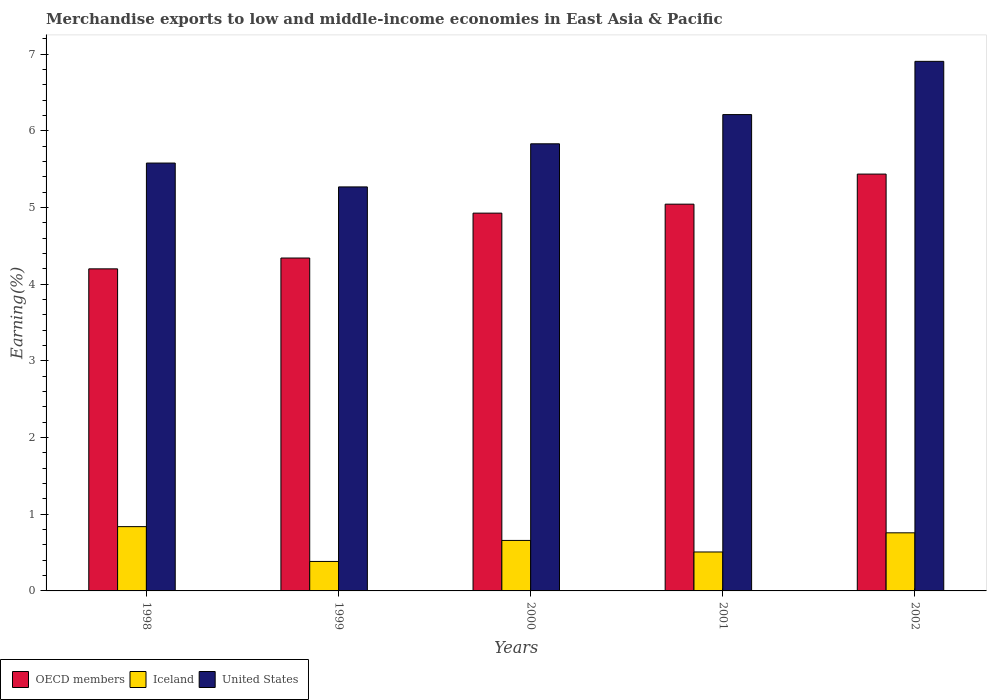How many different coloured bars are there?
Keep it short and to the point. 3. Are the number of bars per tick equal to the number of legend labels?
Make the answer very short. Yes. Are the number of bars on each tick of the X-axis equal?
Your answer should be very brief. Yes. How many bars are there on the 3rd tick from the left?
Keep it short and to the point. 3. How many bars are there on the 5th tick from the right?
Offer a very short reply. 3. What is the percentage of amount earned from merchandise exports in United States in 2000?
Give a very brief answer. 5.83. Across all years, what is the maximum percentage of amount earned from merchandise exports in OECD members?
Provide a succinct answer. 5.44. Across all years, what is the minimum percentage of amount earned from merchandise exports in United States?
Your response must be concise. 5.27. In which year was the percentage of amount earned from merchandise exports in Iceland maximum?
Offer a terse response. 1998. In which year was the percentage of amount earned from merchandise exports in United States minimum?
Your response must be concise. 1999. What is the total percentage of amount earned from merchandise exports in Iceland in the graph?
Your answer should be compact. 3.15. What is the difference between the percentage of amount earned from merchandise exports in Iceland in 2001 and that in 2002?
Your answer should be very brief. -0.25. What is the difference between the percentage of amount earned from merchandise exports in Iceland in 2001 and the percentage of amount earned from merchandise exports in OECD members in 2002?
Provide a succinct answer. -4.93. What is the average percentage of amount earned from merchandise exports in Iceland per year?
Your answer should be compact. 0.63. In the year 2000, what is the difference between the percentage of amount earned from merchandise exports in Iceland and percentage of amount earned from merchandise exports in OECD members?
Provide a short and direct response. -4.27. What is the ratio of the percentage of amount earned from merchandise exports in OECD members in 2000 to that in 2002?
Give a very brief answer. 0.91. What is the difference between the highest and the second highest percentage of amount earned from merchandise exports in Iceland?
Provide a short and direct response. 0.08. What is the difference between the highest and the lowest percentage of amount earned from merchandise exports in Iceland?
Give a very brief answer. 0.45. In how many years, is the percentage of amount earned from merchandise exports in Iceland greater than the average percentage of amount earned from merchandise exports in Iceland taken over all years?
Offer a very short reply. 3. Is the sum of the percentage of amount earned from merchandise exports in OECD members in 1998 and 2002 greater than the maximum percentage of amount earned from merchandise exports in United States across all years?
Your response must be concise. Yes. What does the 2nd bar from the left in 1998 represents?
Ensure brevity in your answer.  Iceland. What does the 1st bar from the right in 1998 represents?
Your response must be concise. United States. Is it the case that in every year, the sum of the percentage of amount earned from merchandise exports in OECD members and percentage of amount earned from merchandise exports in United States is greater than the percentage of amount earned from merchandise exports in Iceland?
Provide a succinct answer. Yes. How many bars are there?
Your response must be concise. 15. Are all the bars in the graph horizontal?
Your response must be concise. No. What is the difference between two consecutive major ticks on the Y-axis?
Offer a terse response. 1. Are the values on the major ticks of Y-axis written in scientific E-notation?
Offer a terse response. No. Does the graph contain any zero values?
Keep it short and to the point. No. Does the graph contain grids?
Provide a succinct answer. No. How are the legend labels stacked?
Offer a very short reply. Horizontal. What is the title of the graph?
Your answer should be compact. Merchandise exports to low and middle-income economies in East Asia & Pacific. Does "Fiji" appear as one of the legend labels in the graph?
Your answer should be compact. No. What is the label or title of the X-axis?
Ensure brevity in your answer.  Years. What is the label or title of the Y-axis?
Your response must be concise. Earning(%). What is the Earning(%) in OECD members in 1998?
Your answer should be compact. 4.2. What is the Earning(%) in Iceland in 1998?
Your answer should be compact. 0.84. What is the Earning(%) of United States in 1998?
Offer a terse response. 5.58. What is the Earning(%) of OECD members in 1999?
Provide a short and direct response. 4.34. What is the Earning(%) in Iceland in 1999?
Keep it short and to the point. 0.38. What is the Earning(%) of United States in 1999?
Your answer should be compact. 5.27. What is the Earning(%) in OECD members in 2000?
Keep it short and to the point. 4.93. What is the Earning(%) of Iceland in 2000?
Provide a succinct answer. 0.66. What is the Earning(%) in United States in 2000?
Your answer should be very brief. 5.83. What is the Earning(%) in OECD members in 2001?
Your answer should be compact. 5.05. What is the Earning(%) of Iceland in 2001?
Make the answer very short. 0.51. What is the Earning(%) of United States in 2001?
Give a very brief answer. 6.21. What is the Earning(%) in OECD members in 2002?
Your response must be concise. 5.44. What is the Earning(%) in Iceland in 2002?
Your answer should be very brief. 0.76. What is the Earning(%) in United States in 2002?
Give a very brief answer. 6.91. Across all years, what is the maximum Earning(%) of OECD members?
Offer a very short reply. 5.44. Across all years, what is the maximum Earning(%) in Iceland?
Give a very brief answer. 0.84. Across all years, what is the maximum Earning(%) of United States?
Keep it short and to the point. 6.91. Across all years, what is the minimum Earning(%) of OECD members?
Your answer should be very brief. 4.2. Across all years, what is the minimum Earning(%) in Iceland?
Ensure brevity in your answer.  0.38. Across all years, what is the minimum Earning(%) in United States?
Offer a very short reply. 5.27. What is the total Earning(%) in OECD members in the graph?
Your answer should be very brief. 23.96. What is the total Earning(%) of Iceland in the graph?
Your response must be concise. 3.15. What is the total Earning(%) in United States in the graph?
Provide a succinct answer. 29.81. What is the difference between the Earning(%) in OECD members in 1998 and that in 1999?
Ensure brevity in your answer.  -0.14. What is the difference between the Earning(%) of Iceland in 1998 and that in 1999?
Provide a short and direct response. 0.45. What is the difference between the Earning(%) of United States in 1998 and that in 1999?
Ensure brevity in your answer.  0.31. What is the difference between the Earning(%) in OECD members in 1998 and that in 2000?
Your answer should be compact. -0.73. What is the difference between the Earning(%) of Iceland in 1998 and that in 2000?
Your answer should be compact. 0.18. What is the difference between the Earning(%) of United States in 1998 and that in 2000?
Your answer should be compact. -0.25. What is the difference between the Earning(%) in OECD members in 1998 and that in 2001?
Offer a terse response. -0.84. What is the difference between the Earning(%) in Iceland in 1998 and that in 2001?
Provide a short and direct response. 0.33. What is the difference between the Earning(%) in United States in 1998 and that in 2001?
Provide a short and direct response. -0.63. What is the difference between the Earning(%) in OECD members in 1998 and that in 2002?
Offer a very short reply. -1.24. What is the difference between the Earning(%) of Iceland in 1998 and that in 2002?
Make the answer very short. 0.08. What is the difference between the Earning(%) in United States in 1998 and that in 2002?
Make the answer very short. -1.33. What is the difference between the Earning(%) of OECD members in 1999 and that in 2000?
Provide a short and direct response. -0.59. What is the difference between the Earning(%) in Iceland in 1999 and that in 2000?
Provide a succinct answer. -0.27. What is the difference between the Earning(%) of United States in 1999 and that in 2000?
Provide a succinct answer. -0.56. What is the difference between the Earning(%) in OECD members in 1999 and that in 2001?
Make the answer very short. -0.7. What is the difference between the Earning(%) of Iceland in 1999 and that in 2001?
Offer a very short reply. -0.12. What is the difference between the Earning(%) in United States in 1999 and that in 2001?
Provide a succinct answer. -0.94. What is the difference between the Earning(%) of OECD members in 1999 and that in 2002?
Give a very brief answer. -1.09. What is the difference between the Earning(%) in Iceland in 1999 and that in 2002?
Provide a short and direct response. -0.37. What is the difference between the Earning(%) in United States in 1999 and that in 2002?
Ensure brevity in your answer.  -1.64. What is the difference between the Earning(%) of OECD members in 2000 and that in 2001?
Ensure brevity in your answer.  -0.12. What is the difference between the Earning(%) in Iceland in 2000 and that in 2001?
Your answer should be compact. 0.15. What is the difference between the Earning(%) in United States in 2000 and that in 2001?
Give a very brief answer. -0.38. What is the difference between the Earning(%) of OECD members in 2000 and that in 2002?
Offer a very short reply. -0.51. What is the difference between the Earning(%) of Iceland in 2000 and that in 2002?
Make the answer very short. -0.1. What is the difference between the Earning(%) in United States in 2000 and that in 2002?
Your response must be concise. -1.08. What is the difference between the Earning(%) in OECD members in 2001 and that in 2002?
Give a very brief answer. -0.39. What is the difference between the Earning(%) in United States in 2001 and that in 2002?
Your response must be concise. -0.69. What is the difference between the Earning(%) of OECD members in 1998 and the Earning(%) of Iceland in 1999?
Keep it short and to the point. 3.82. What is the difference between the Earning(%) in OECD members in 1998 and the Earning(%) in United States in 1999?
Offer a terse response. -1.07. What is the difference between the Earning(%) of Iceland in 1998 and the Earning(%) of United States in 1999?
Your response must be concise. -4.43. What is the difference between the Earning(%) of OECD members in 1998 and the Earning(%) of Iceland in 2000?
Your answer should be compact. 3.54. What is the difference between the Earning(%) of OECD members in 1998 and the Earning(%) of United States in 2000?
Offer a terse response. -1.63. What is the difference between the Earning(%) of Iceland in 1998 and the Earning(%) of United States in 2000?
Ensure brevity in your answer.  -4.99. What is the difference between the Earning(%) in OECD members in 1998 and the Earning(%) in Iceland in 2001?
Your response must be concise. 3.69. What is the difference between the Earning(%) in OECD members in 1998 and the Earning(%) in United States in 2001?
Keep it short and to the point. -2.01. What is the difference between the Earning(%) in Iceland in 1998 and the Earning(%) in United States in 2001?
Your answer should be compact. -5.38. What is the difference between the Earning(%) in OECD members in 1998 and the Earning(%) in Iceland in 2002?
Your answer should be compact. 3.44. What is the difference between the Earning(%) in OECD members in 1998 and the Earning(%) in United States in 2002?
Offer a terse response. -2.71. What is the difference between the Earning(%) of Iceland in 1998 and the Earning(%) of United States in 2002?
Give a very brief answer. -6.07. What is the difference between the Earning(%) in OECD members in 1999 and the Earning(%) in Iceland in 2000?
Your answer should be very brief. 3.68. What is the difference between the Earning(%) of OECD members in 1999 and the Earning(%) of United States in 2000?
Keep it short and to the point. -1.49. What is the difference between the Earning(%) of Iceland in 1999 and the Earning(%) of United States in 2000?
Give a very brief answer. -5.45. What is the difference between the Earning(%) of OECD members in 1999 and the Earning(%) of Iceland in 2001?
Provide a short and direct response. 3.83. What is the difference between the Earning(%) in OECD members in 1999 and the Earning(%) in United States in 2001?
Give a very brief answer. -1.87. What is the difference between the Earning(%) of Iceland in 1999 and the Earning(%) of United States in 2001?
Your answer should be compact. -5.83. What is the difference between the Earning(%) of OECD members in 1999 and the Earning(%) of Iceland in 2002?
Offer a terse response. 3.58. What is the difference between the Earning(%) in OECD members in 1999 and the Earning(%) in United States in 2002?
Your answer should be very brief. -2.57. What is the difference between the Earning(%) in Iceland in 1999 and the Earning(%) in United States in 2002?
Provide a succinct answer. -6.52. What is the difference between the Earning(%) in OECD members in 2000 and the Earning(%) in Iceland in 2001?
Your answer should be compact. 4.42. What is the difference between the Earning(%) of OECD members in 2000 and the Earning(%) of United States in 2001?
Your response must be concise. -1.29. What is the difference between the Earning(%) of Iceland in 2000 and the Earning(%) of United States in 2001?
Your answer should be compact. -5.55. What is the difference between the Earning(%) of OECD members in 2000 and the Earning(%) of Iceland in 2002?
Provide a succinct answer. 4.17. What is the difference between the Earning(%) of OECD members in 2000 and the Earning(%) of United States in 2002?
Your answer should be compact. -1.98. What is the difference between the Earning(%) of Iceland in 2000 and the Earning(%) of United States in 2002?
Offer a very short reply. -6.25. What is the difference between the Earning(%) in OECD members in 2001 and the Earning(%) in Iceland in 2002?
Give a very brief answer. 4.29. What is the difference between the Earning(%) of OECD members in 2001 and the Earning(%) of United States in 2002?
Your answer should be compact. -1.86. What is the difference between the Earning(%) of Iceland in 2001 and the Earning(%) of United States in 2002?
Make the answer very short. -6.4. What is the average Earning(%) of OECD members per year?
Ensure brevity in your answer.  4.79. What is the average Earning(%) in Iceland per year?
Ensure brevity in your answer.  0.63. What is the average Earning(%) in United States per year?
Offer a terse response. 5.96. In the year 1998, what is the difference between the Earning(%) in OECD members and Earning(%) in Iceland?
Make the answer very short. 3.36. In the year 1998, what is the difference between the Earning(%) in OECD members and Earning(%) in United States?
Give a very brief answer. -1.38. In the year 1998, what is the difference between the Earning(%) of Iceland and Earning(%) of United States?
Keep it short and to the point. -4.74. In the year 1999, what is the difference between the Earning(%) in OECD members and Earning(%) in Iceland?
Provide a succinct answer. 3.96. In the year 1999, what is the difference between the Earning(%) of OECD members and Earning(%) of United States?
Keep it short and to the point. -0.93. In the year 1999, what is the difference between the Earning(%) in Iceland and Earning(%) in United States?
Keep it short and to the point. -4.89. In the year 2000, what is the difference between the Earning(%) in OECD members and Earning(%) in Iceland?
Your response must be concise. 4.27. In the year 2000, what is the difference between the Earning(%) in OECD members and Earning(%) in United States?
Make the answer very short. -0.9. In the year 2000, what is the difference between the Earning(%) in Iceland and Earning(%) in United States?
Provide a succinct answer. -5.17. In the year 2001, what is the difference between the Earning(%) in OECD members and Earning(%) in Iceland?
Give a very brief answer. 4.54. In the year 2001, what is the difference between the Earning(%) in OECD members and Earning(%) in United States?
Make the answer very short. -1.17. In the year 2001, what is the difference between the Earning(%) of Iceland and Earning(%) of United States?
Offer a very short reply. -5.71. In the year 2002, what is the difference between the Earning(%) in OECD members and Earning(%) in Iceland?
Offer a very short reply. 4.68. In the year 2002, what is the difference between the Earning(%) in OECD members and Earning(%) in United States?
Ensure brevity in your answer.  -1.47. In the year 2002, what is the difference between the Earning(%) of Iceland and Earning(%) of United States?
Keep it short and to the point. -6.15. What is the ratio of the Earning(%) in OECD members in 1998 to that in 1999?
Provide a succinct answer. 0.97. What is the ratio of the Earning(%) of Iceland in 1998 to that in 1999?
Offer a very short reply. 2.18. What is the ratio of the Earning(%) of United States in 1998 to that in 1999?
Your response must be concise. 1.06. What is the ratio of the Earning(%) in OECD members in 1998 to that in 2000?
Offer a terse response. 0.85. What is the ratio of the Earning(%) in Iceland in 1998 to that in 2000?
Provide a succinct answer. 1.27. What is the ratio of the Earning(%) of OECD members in 1998 to that in 2001?
Make the answer very short. 0.83. What is the ratio of the Earning(%) of Iceland in 1998 to that in 2001?
Provide a succinct answer. 1.65. What is the ratio of the Earning(%) of United States in 1998 to that in 2001?
Your response must be concise. 0.9. What is the ratio of the Earning(%) in OECD members in 1998 to that in 2002?
Keep it short and to the point. 0.77. What is the ratio of the Earning(%) in Iceland in 1998 to that in 2002?
Keep it short and to the point. 1.11. What is the ratio of the Earning(%) of United States in 1998 to that in 2002?
Keep it short and to the point. 0.81. What is the ratio of the Earning(%) of OECD members in 1999 to that in 2000?
Provide a short and direct response. 0.88. What is the ratio of the Earning(%) of Iceland in 1999 to that in 2000?
Keep it short and to the point. 0.58. What is the ratio of the Earning(%) in United States in 1999 to that in 2000?
Your answer should be very brief. 0.9. What is the ratio of the Earning(%) of OECD members in 1999 to that in 2001?
Provide a succinct answer. 0.86. What is the ratio of the Earning(%) in Iceland in 1999 to that in 2001?
Provide a succinct answer. 0.76. What is the ratio of the Earning(%) in United States in 1999 to that in 2001?
Ensure brevity in your answer.  0.85. What is the ratio of the Earning(%) of OECD members in 1999 to that in 2002?
Offer a terse response. 0.8. What is the ratio of the Earning(%) of Iceland in 1999 to that in 2002?
Give a very brief answer. 0.51. What is the ratio of the Earning(%) of United States in 1999 to that in 2002?
Provide a succinct answer. 0.76. What is the ratio of the Earning(%) of OECD members in 2000 to that in 2001?
Your answer should be compact. 0.98. What is the ratio of the Earning(%) of Iceland in 2000 to that in 2001?
Provide a short and direct response. 1.3. What is the ratio of the Earning(%) of United States in 2000 to that in 2001?
Your response must be concise. 0.94. What is the ratio of the Earning(%) of OECD members in 2000 to that in 2002?
Offer a terse response. 0.91. What is the ratio of the Earning(%) of Iceland in 2000 to that in 2002?
Your response must be concise. 0.87. What is the ratio of the Earning(%) in United States in 2000 to that in 2002?
Offer a terse response. 0.84. What is the ratio of the Earning(%) of OECD members in 2001 to that in 2002?
Ensure brevity in your answer.  0.93. What is the ratio of the Earning(%) in Iceland in 2001 to that in 2002?
Ensure brevity in your answer.  0.67. What is the ratio of the Earning(%) in United States in 2001 to that in 2002?
Provide a short and direct response. 0.9. What is the difference between the highest and the second highest Earning(%) in OECD members?
Provide a short and direct response. 0.39. What is the difference between the highest and the second highest Earning(%) of Iceland?
Provide a succinct answer. 0.08. What is the difference between the highest and the second highest Earning(%) of United States?
Keep it short and to the point. 0.69. What is the difference between the highest and the lowest Earning(%) in OECD members?
Give a very brief answer. 1.24. What is the difference between the highest and the lowest Earning(%) of Iceland?
Provide a succinct answer. 0.45. What is the difference between the highest and the lowest Earning(%) in United States?
Offer a terse response. 1.64. 